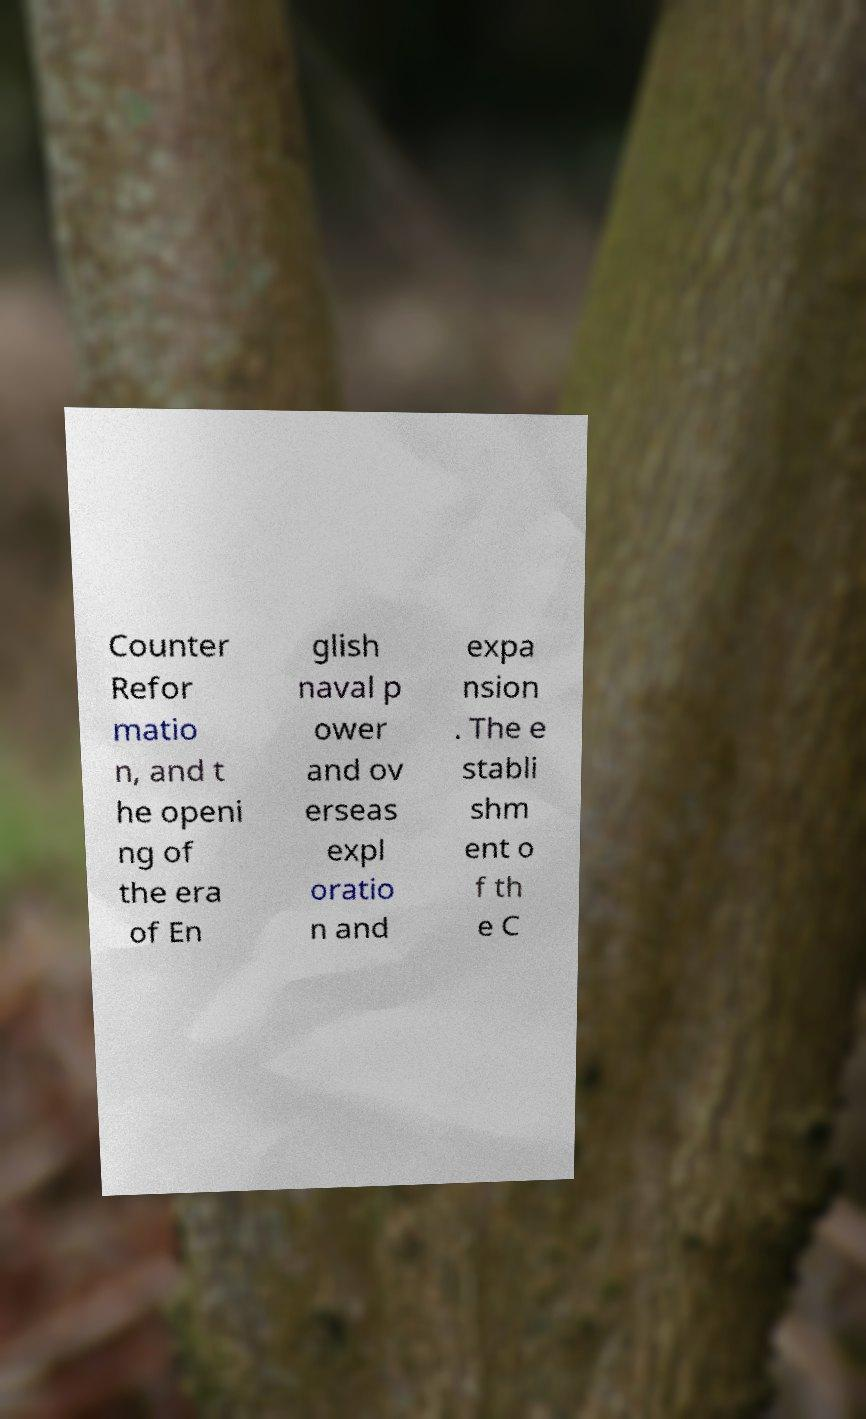I need the written content from this picture converted into text. Can you do that? Counter Refor matio n, and t he openi ng of the era of En glish naval p ower and ov erseas expl oratio n and expa nsion . The e stabli shm ent o f th e C 